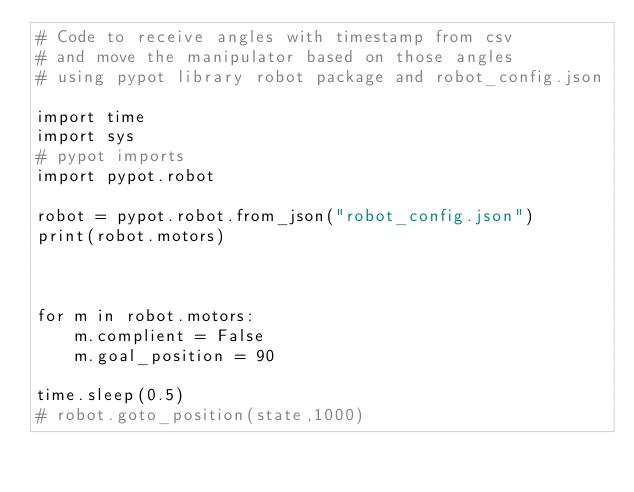Convert code to text. <code><loc_0><loc_0><loc_500><loc_500><_Python_># Code to receive angles with timestamp from csv
# and move the manipulator based on those angles
# using pypot library robot package and robot_config.json

import time
import sys
# pypot imports
import pypot.robot

robot = pypot.robot.from_json("robot_config.json")
print(robot.motors)



for m in robot.motors:
    m.complient = False
    m.goal_position = 90

time.sleep(0.5)
# robot.goto_position(state,1000)
</code> 